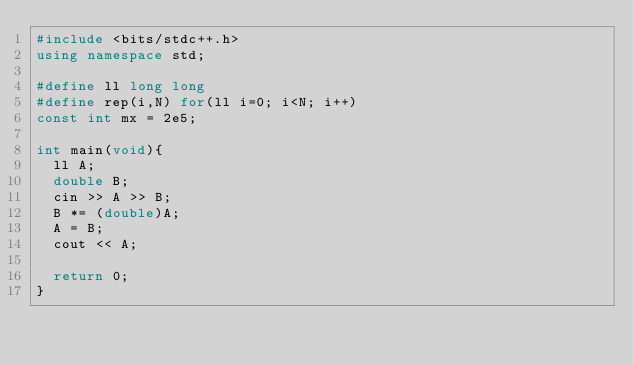Convert code to text. <code><loc_0><loc_0><loc_500><loc_500><_C++_>#include <bits/stdc++.h>
using namespace std;

#define ll long long
#define rep(i,N) for(ll i=0; i<N; i++)
const int mx = 2e5;

int main(void){
  ll A;
  double B;
  cin >> A >> B;
  B *= (double)A;
  A = B;
  cout << A;
  
  return 0;
}</code> 